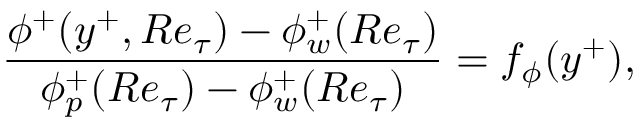<formula> <loc_0><loc_0><loc_500><loc_500>\frac { \phi ^ { + } ( y ^ { + } , R e _ { \tau } ) - \phi _ { w } ^ { + } ( R e _ { \tau } ) } { \phi _ { p } ^ { + } ( R e _ { \tau } ) - \phi _ { w } ^ { + } ( R e _ { \tau } ) } = f _ { \phi } ( y ^ { + } ) ,</formula> 